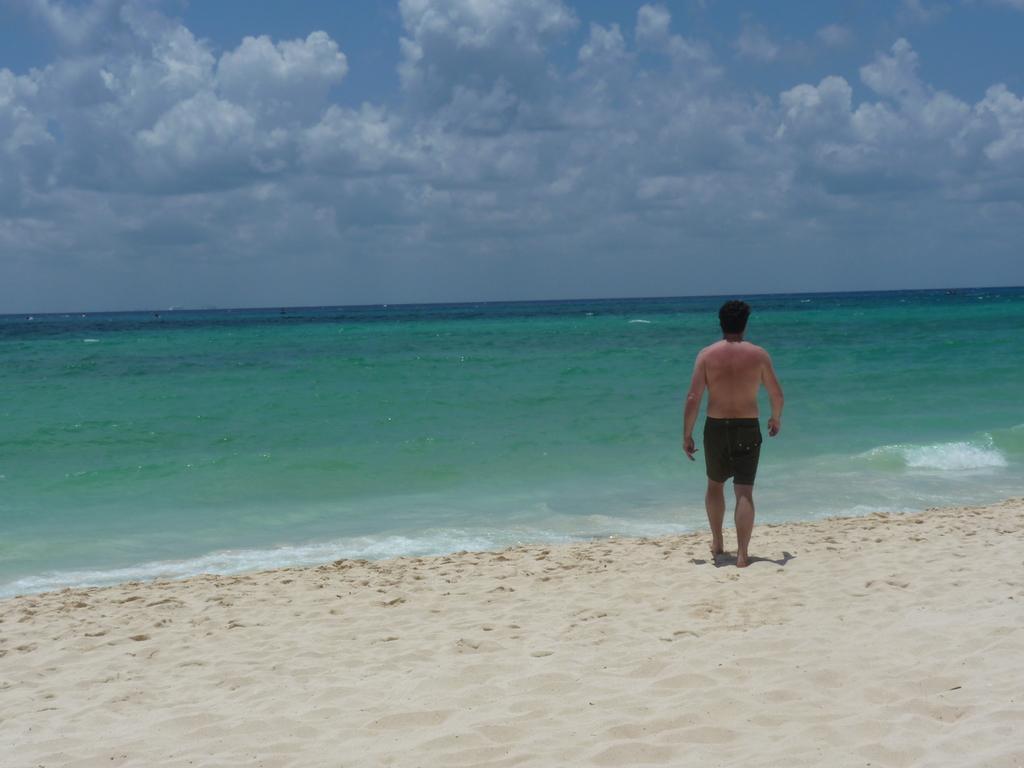How would you summarize this image in a sentence or two? In this picture we can see a person standing on sand and in the background we can see water and sky with clouds. 